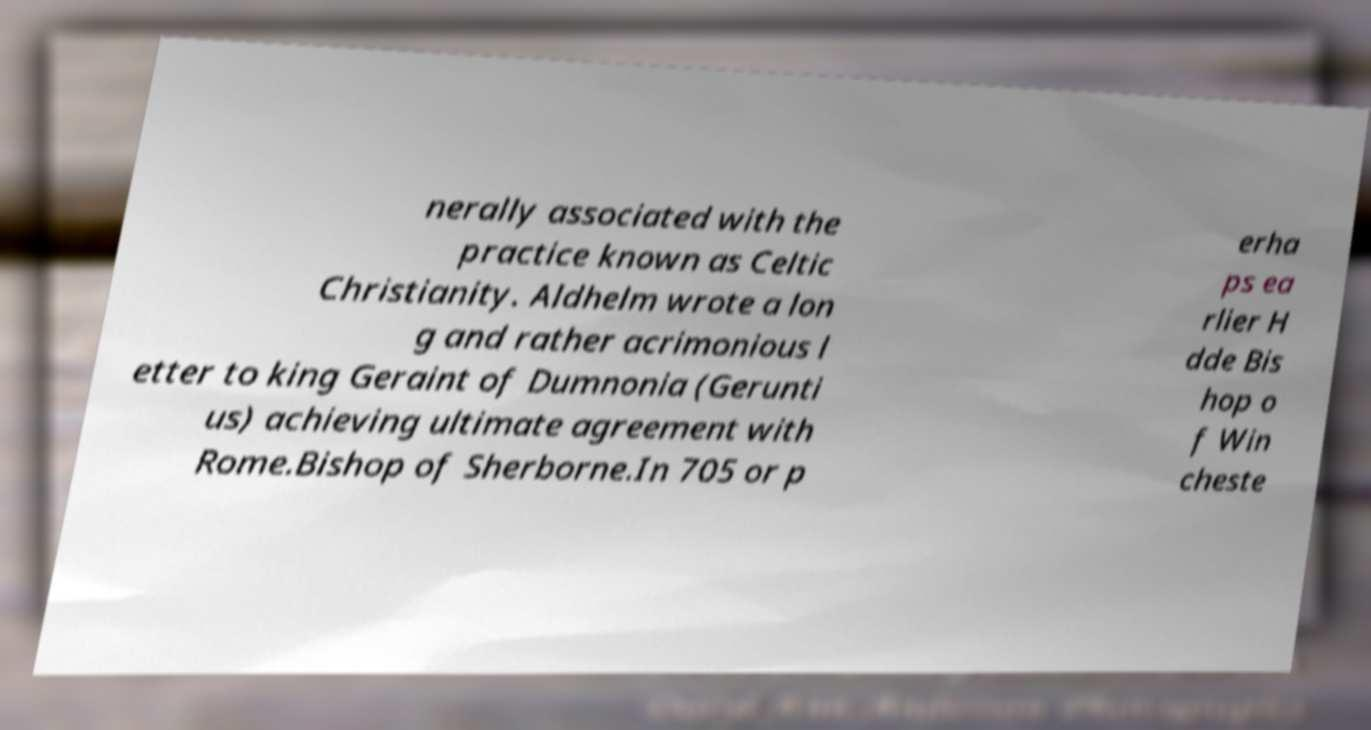For documentation purposes, I need the text within this image transcribed. Could you provide that? nerally associated with the practice known as Celtic Christianity. Aldhelm wrote a lon g and rather acrimonious l etter to king Geraint of Dumnonia (Gerunti us) achieving ultimate agreement with Rome.Bishop of Sherborne.In 705 or p erha ps ea rlier H dde Bis hop o f Win cheste 